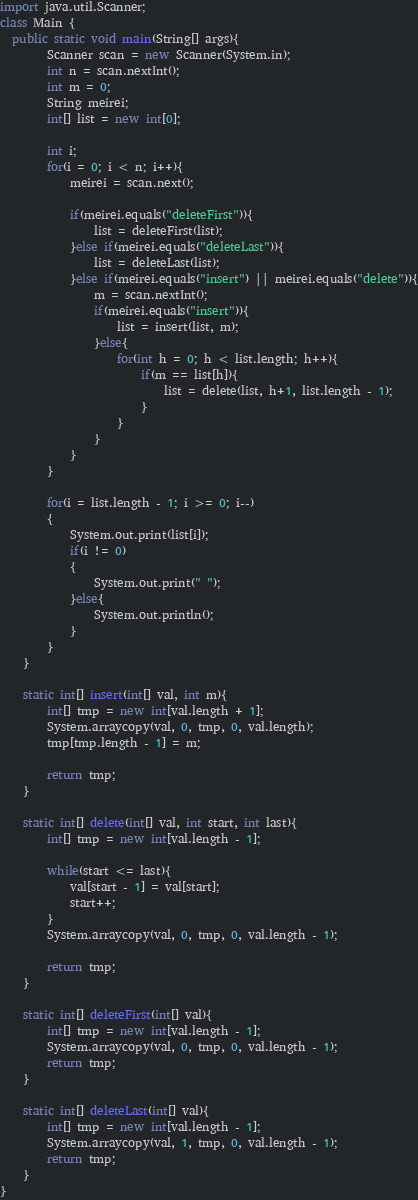Convert code to text. <code><loc_0><loc_0><loc_500><loc_500><_Java_>import java.util.Scanner;
class Main {
  public static void main(String[] args){
		Scanner scan = new Scanner(System.in);
		int n = scan.nextInt();
		int m = 0;
		String meirei;
		int[] list = new int[0];

		int i;
		for(i = 0; i < n; i++){
			meirei = scan.next();

			if(meirei.equals("deleteFirst")){
				list = deleteFirst(list);
			}else if(meirei.equals("deleteLast")){
				list = deleteLast(list);
			}else if(meirei.equals("insert") || meirei.equals("delete")){
				m = scan.nextInt();
				if(meirei.equals("insert")){
					list = insert(list, m);
				}else{
					for(int h = 0; h < list.length; h++){
						if(m == list[h]){
							list = delete(list, h+1, list.length - 1);
						}
					}
				}
			}
		}

		for(i = list.length - 1; i >= 0; i--)
		{
			System.out.print(list[i]);
			if(i != 0)
			{
				System.out.print(" ");
			}else{
				System.out.println();
			}
		}
	}
	
	static int[] insert(int[] val, int m){
		int[] tmp = new int[val.length + 1];
		System.arraycopy(val, 0, tmp, 0, val.length);
		tmp[tmp.length - 1] = m;
		
		return tmp;
	}
	
	static int[] delete(int[] val, int start, int last){
		int[] tmp = new int[val.length - 1];
		
		while(start <= last){
			val[start - 1] = val[start];
			start++;
		}
		System.arraycopy(val, 0, tmp, 0, val.length - 1);
		
		return tmp; 
	}
	
	static int[] deleteFirst(int[] val){
		int[] tmp = new int[val.length - 1];
		System.arraycopy(val, 0, tmp, 0, val.length - 1);
		return tmp;
	}
	
	static int[] deleteLast(int[] val){
		int[] tmp = new int[val.length - 1];
		System.arraycopy(val, 1, tmp, 0, val.length - 1);
		return tmp;
	}
}</code> 